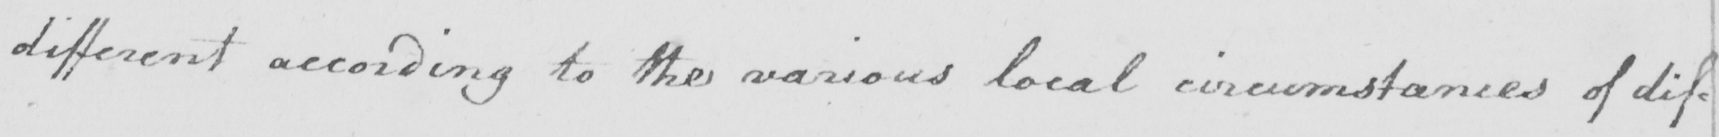Please transcribe the handwritten text in this image. different according to the various local circumstances of dif : 